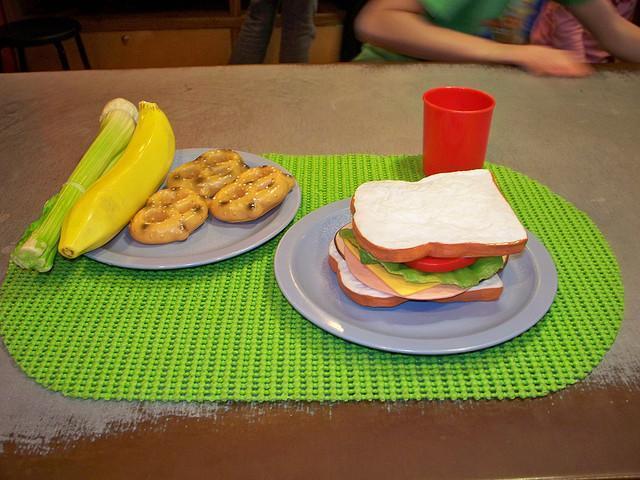How many people are there?
Give a very brief answer. 2. 